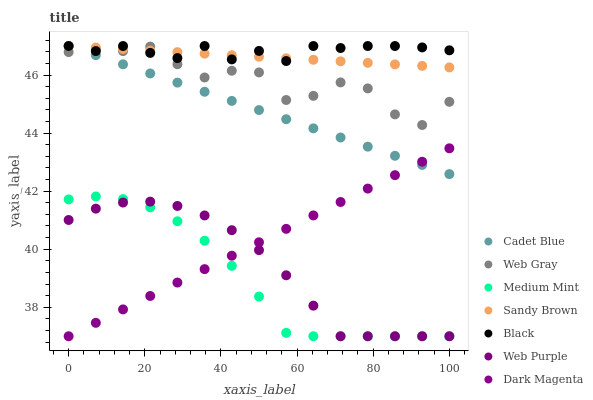Does Medium Mint have the minimum area under the curve?
Answer yes or no. Yes. Does Black have the maximum area under the curve?
Answer yes or no. Yes. Does Cadet Blue have the minimum area under the curve?
Answer yes or no. No. Does Cadet Blue have the maximum area under the curve?
Answer yes or no. No. Is Sandy Brown the smoothest?
Answer yes or no. Yes. Is Web Gray the roughest?
Answer yes or no. Yes. Is Cadet Blue the smoothest?
Answer yes or no. No. Is Cadet Blue the roughest?
Answer yes or no. No. Does Medium Mint have the lowest value?
Answer yes or no. Yes. Does Cadet Blue have the lowest value?
Answer yes or no. No. Does Sandy Brown have the highest value?
Answer yes or no. Yes. Does Dark Magenta have the highest value?
Answer yes or no. No. Is Medium Mint less than Web Gray?
Answer yes or no. Yes. Is Web Gray greater than Medium Mint?
Answer yes or no. Yes. Does Sandy Brown intersect Cadet Blue?
Answer yes or no. Yes. Is Sandy Brown less than Cadet Blue?
Answer yes or no. No. Is Sandy Brown greater than Cadet Blue?
Answer yes or no. No. Does Medium Mint intersect Web Gray?
Answer yes or no. No. 